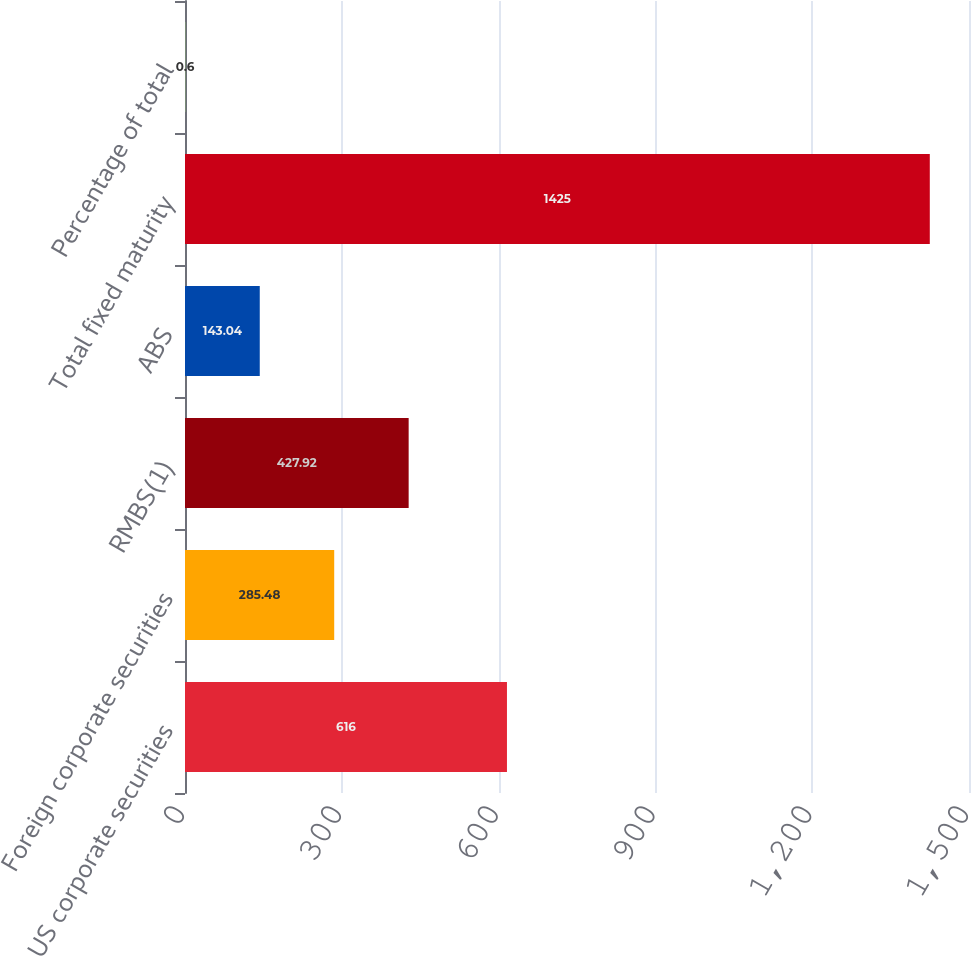Convert chart. <chart><loc_0><loc_0><loc_500><loc_500><bar_chart><fcel>US corporate securities<fcel>Foreign corporate securities<fcel>RMBS(1)<fcel>ABS<fcel>Total fixed maturity<fcel>Percentage of total<nl><fcel>616<fcel>285.48<fcel>427.92<fcel>143.04<fcel>1425<fcel>0.6<nl></chart> 